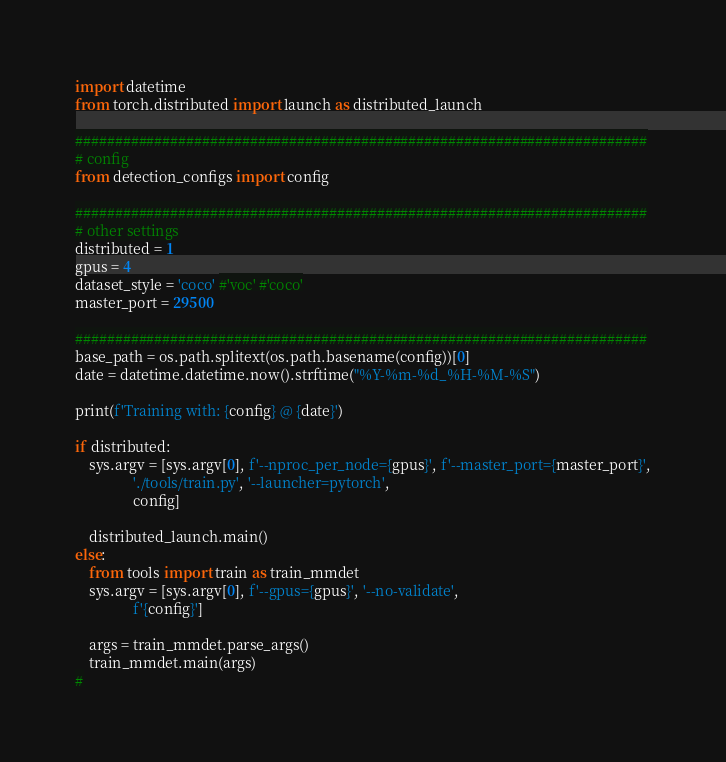<code> <loc_0><loc_0><loc_500><loc_500><_Python_>import datetime
from torch.distributed import launch as distributed_launch

########################################################################
# config
from detection_configs import config

########################################################################
# other settings
distributed = 1
gpus = 4
dataset_style = 'coco' #'voc' #'coco'
master_port = 29500

########################################################################
base_path = os.path.splitext(os.path.basename(config))[0]
date = datetime.datetime.now().strftime("%Y-%m-%d_%H-%M-%S")

print(f'Training with: {config} @ {date}')

if distributed:
    sys.argv = [sys.argv[0], f'--nproc_per_node={gpus}', f'--master_port={master_port}',
                './tools/train.py', '--launcher=pytorch',
                config]

    distributed_launch.main()
else:
    from tools import train as train_mmdet
    sys.argv = [sys.argv[0], f'--gpus={gpus}', '--no-validate',
                f'{config}']

    args = train_mmdet.parse_args()
    train_mmdet.main(args)
#
</code> 